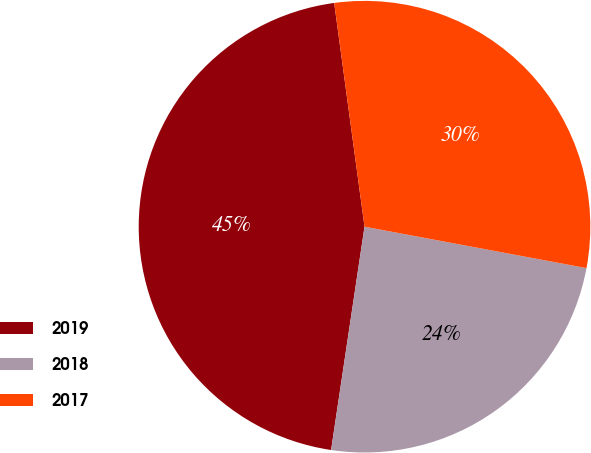<chart> <loc_0><loc_0><loc_500><loc_500><pie_chart><fcel>2019<fcel>2018<fcel>2017<nl><fcel>45.49%<fcel>24.43%<fcel>30.08%<nl></chart> 